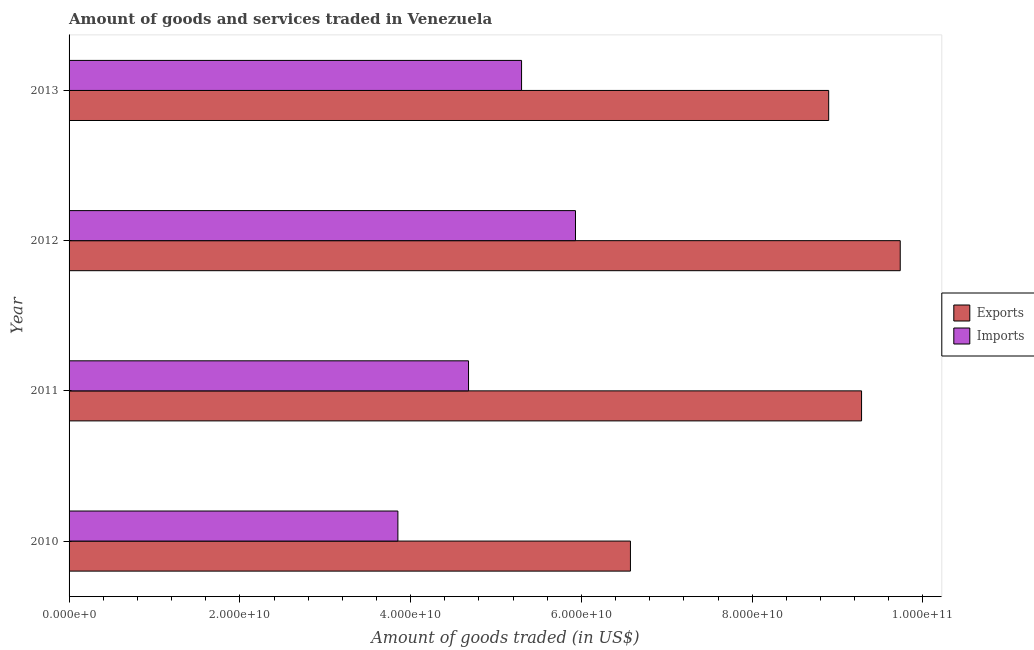How many different coloured bars are there?
Give a very brief answer. 2. Are the number of bars per tick equal to the number of legend labels?
Give a very brief answer. Yes. What is the amount of goods exported in 2013?
Ensure brevity in your answer.  8.90e+1. Across all years, what is the maximum amount of goods exported?
Make the answer very short. 9.73e+1. Across all years, what is the minimum amount of goods exported?
Provide a short and direct response. 6.57e+1. In which year was the amount of goods imported maximum?
Provide a succinct answer. 2012. What is the total amount of goods imported in the graph?
Keep it short and to the point. 1.98e+11. What is the difference between the amount of goods imported in 2011 and that in 2012?
Keep it short and to the point. -1.25e+1. What is the difference between the amount of goods exported in 2010 and the amount of goods imported in 2013?
Give a very brief answer. 1.28e+1. What is the average amount of goods exported per year?
Keep it short and to the point. 8.62e+1. In the year 2013, what is the difference between the amount of goods imported and amount of goods exported?
Your answer should be very brief. -3.60e+1. In how many years, is the amount of goods imported greater than 68000000000 US$?
Make the answer very short. 0. What is the ratio of the amount of goods exported in 2010 to that in 2011?
Your response must be concise. 0.71. Is the amount of goods imported in 2011 less than that in 2013?
Provide a short and direct response. Yes. Is the difference between the amount of goods imported in 2010 and 2012 greater than the difference between the amount of goods exported in 2010 and 2012?
Make the answer very short. Yes. What is the difference between the highest and the second highest amount of goods exported?
Your answer should be very brief. 4.53e+09. What is the difference between the highest and the lowest amount of goods exported?
Make the answer very short. 3.16e+1. What does the 2nd bar from the top in 2013 represents?
Give a very brief answer. Exports. What does the 1st bar from the bottom in 2010 represents?
Offer a terse response. Exports. How many years are there in the graph?
Your answer should be compact. 4. Are the values on the major ticks of X-axis written in scientific E-notation?
Keep it short and to the point. Yes. Where does the legend appear in the graph?
Provide a succinct answer. Center right. How many legend labels are there?
Ensure brevity in your answer.  2. How are the legend labels stacked?
Your answer should be compact. Vertical. What is the title of the graph?
Your answer should be very brief. Amount of goods and services traded in Venezuela. Does "By country of asylum" appear as one of the legend labels in the graph?
Offer a very short reply. No. What is the label or title of the X-axis?
Make the answer very short. Amount of goods traded (in US$). What is the Amount of goods traded (in US$) in Exports in 2010?
Give a very brief answer. 6.57e+1. What is the Amount of goods traded (in US$) of Imports in 2010?
Offer a terse response. 3.85e+1. What is the Amount of goods traded (in US$) of Exports in 2011?
Make the answer very short. 9.28e+1. What is the Amount of goods traded (in US$) in Imports in 2011?
Provide a short and direct response. 4.68e+1. What is the Amount of goods traded (in US$) in Exports in 2012?
Your answer should be very brief. 9.73e+1. What is the Amount of goods traded (in US$) of Imports in 2012?
Your response must be concise. 5.93e+1. What is the Amount of goods traded (in US$) of Exports in 2013?
Your answer should be compact. 8.90e+1. What is the Amount of goods traded (in US$) of Imports in 2013?
Provide a short and direct response. 5.30e+1. Across all years, what is the maximum Amount of goods traded (in US$) of Exports?
Your answer should be compact. 9.73e+1. Across all years, what is the maximum Amount of goods traded (in US$) in Imports?
Ensure brevity in your answer.  5.93e+1. Across all years, what is the minimum Amount of goods traded (in US$) in Exports?
Give a very brief answer. 6.57e+1. Across all years, what is the minimum Amount of goods traded (in US$) in Imports?
Give a very brief answer. 3.85e+1. What is the total Amount of goods traded (in US$) in Exports in the graph?
Offer a terse response. 3.45e+11. What is the total Amount of goods traded (in US$) of Imports in the graph?
Ensure brevity in your answer.  1.98e+11. What is the difference between the Amount of goods traded (in US$) in Exports in 2010 and that in 2011?
Give a very brief answer. -2.71e+1. What is the difference between the Amount of goods traded (in US$) of Imports in 2010 and that in 2011?
Your answer should be very brief. -8.27e+09. What is the difference between the Amount of goods traded (in US$) of Exports in 2010 and that in 2012?
Offer a terse response. -3.16e+1. What is the difference between the Amount of goods traded (in US$) of Imports in 2010 and that in 2012?
Ensure brevity in your answer.  -2.08e+1. What is the difference between the Amount of goods traded (in US$) in Exports in 2010 and that in 2013?
Offer a very short reply. -2.32e+1. What is the difference between the Amount of goods traded (in US$) in Imports in 2010 and that in 2013?
Your answer should be very brief. -1.45e+1. What is the difference between the Amount of goods traded (in US$) in Exports in 2011 and that in 2012?
Offer a very short reply. -4.53e+09. What is the difference between the Amount of goods traded (in US$) in Imports in 2011 and that in 2012?
Provide a short and direct response. -1.25e+1. What is the difference between the Amount of goods traded (in US$) of Exports in 2011 and that in 2013?
Make the answer very short. 3.85e+09. What is the difference between the Amount of goods traded (in US$) of Imports in 2011 and that in 2013?
Your answer should be very brief. -6.21e+09. What is the difference between the Amount of goods traded (in US$) of Exports in 2012 and that in 2013?
Ensure brevity in your answer.  8.38e+09. What is the difference between the Amount of goods traded (in US$) of Imports in 2012 and that in 2013?
Your answer should be very brief. 6.31e+09. What is the difference between the Amount of goods traded (in US$) of Exports in 2010 and the Amount of goods traded (in US$) of Imports in 2011?
Provide a short and direct response. 1.90e+1. What is the difference between the Amount of goods traded (in US$) in Exports in 2010 and the Amount of goods traded (in US$) in Imports in 2012?
Give a very brief answer. 6.44e+09. What is the difference between the Amount of goods traded (in US$) of Exports in 2010 and the Amount of goods traded (in US$) of Imports in 2013?
Your answer should be compact. 1.28e+1. What is the difference between the Amount of goods traded (in US$) in Exports in 2011 and the Amount of goods traded (in US$) in Imports in 2012?
Your answer should be compact. 3.35e+1. What is the difference between the Amount of goods traded (in US$) of Exports in 2011 and the Amount of goods traded (in US$) of Imports in 2013?
Offer a terse response. 3.98e+1. What is the difference between the Amount of goods traded (in US$) of Exports in 2012 and the Amount of goods traded (in US$) of Imports in 2013?
Give a very brief answer. 4.43e+1. What is the average Amount of goods traded (in US$) in Exports per year?
Your answer should be compact. 8.62e+1. What is the average Amount of goods traded (in US$) of Imports per year?
Give a very brief answer. 4.94e+1. In the year 2010, what is the difference between the Amount of goods traded (in US$) in Exports and Amount of goods traded (in US$) in Imports?
Make the answer very short. 2.72e+1. In the year 2011, what is the difference between the Amount of goods traded (in US$) of Exports and Amount of goods traded (in US$) of Imports?
Keep it short and to the point. 4.60e+1. In the year 2012, what is the difference between the Amount of goods traded (in US$) of Exports and Amount of goods traded (in US$) of Imports?
Provide a succinct answer. 3.80e+1. In the year 2013, what is the difference between the Amount of goods traded (in US$) of Exports and Amount of goods traded (in US$) of Imports?
Your answer should be very brief. 3.60e+1. What is the ratio of the Amount of goods traded (in US$) of Exports in 2010 to that in 2011?
Give a very brief answer. 0.71. What is the ratio of the Amount of goods traded (in US$) in Imports in 2010 to that in 2011?
Offer a terse response. 0.82. What is the ratio of the Amount of goods traded (in US$) in Exports in 2010 to that in 2012?
Ensure brevity in your answer.  0.68. What is the ratio of the Amount of goods traded (in US$) of Imports in 2010 to that in 2012?
Your answer should be compact. 0.65. What is the ratio of the Amount of goods traded (in US$) of Exports in 2010 to that in 2013?
Keep it short and to the point. 0.74. What is the ratio of the Amount of goods traded (in US$) in Imports in 2010 to that in 2013?
Make the answer very short. 0.73. What is the ratio of the Amount of goods traded (in US$) in Exports in 2011 to that in 2012?
Your response must be concise. 0.95. What is the ratio of the Amount of goods traded (in US$) in Imports in 2011 to that in 2012?
Give a very brief answer. 0.79. What is the ratio of the Amount of goods traded (in US$) in Exports in 2011 to that in 2013?
Your response must be concise. 1.04. What is the ratio of the Amount of goods traded (in US$) in Imports in 2011 to that in 2013?
Give a very brief answer. 0.88. What is the ratio of the Amount of goods traded (in US$) in Exports in 2012 to that in 2013?
Provide a succinct answer. 1.09. What is the ratio of the Amount of goods traded (in US$) of Imports in 2012 to that in 2013?
Your answer should be compact. 1.12. What is the difference between the highest and the second highest Amount of goods traded (in US$) in Exports?
Your answer should be very brief. 4.53e+09. What is the difference between the highest and the second highest Amount of goods traded (in US$) of Imports?
Your response must be concise. 6.31e+09. What is the difference between the highest and the lowest Amount of goods traded (in US$) of Exports?
Ensure brevity in your answer.  3.16e+1. What is the difference between the highest and the lowest Amount of goods traded (in US$) of Imports?
Your answer should be compact. 2.08e+1. 